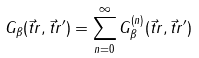Convert formula to latex. <formula><loc_0><loc_0><loc_500><loc_500>G _ { \beta } ( \vec { t } { r } , \vec { t } { r } ^ { \prime } ) = \sum _ { n = 0 } ^ { \infty } G ^ { ( n ) } _ { \beta } ( \vec { t } { r } , \vec { t } { r } ^ { \prime } )</formula> 